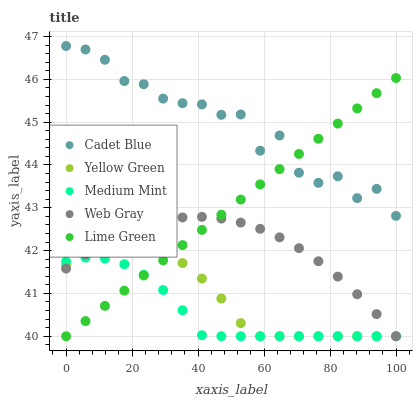Does Medium Mint have the minimum area under the curve?
Answer yes or no. Yes. Does Cadet Blue have the maximum area under the curve?
Answer yes or no. Yes. Does Lime Green have the minimum area under the curve?
Answer yes or no. No. Does Lime Green have the maximum area under the curve?
Answer yes or no. No. Is Lime Green the smoothest?
Answer yes or no. Yes. Is Cadet Blue the roughest?
Answer yes or no. Yes. Is Cadet Blue the smoothest?
Answer yes or no. No. Is Lime Green the roughest?
Answer yes or no. No. Does Medium Mint have the lowest value?
Answer yes or no. Yes. Does Cadet Blue have the lowest value?
Answer yes or no. No. Does Cadet Blue have the highest value?
Answer yes or no. Yes. Does Lime Green have the highest value?
Answer yes or no. No. Is Medium Mint less than Cadet Blue?
Answer yes or no. Yes. Is Cadet Blue greater than Medium Mint?
Answer yes or no. Yes. Does Cadet Blue intersect Lime Green?
Answer yes or no. Yes. Is Cadet Blue less than Lime Green?
Answer yes or no. No. Is Cadet Blue greater than Lime Green?
Answer yes or no. No. Does Medium Mint intersect Cadet Blue?
Answer yes or no. No. 